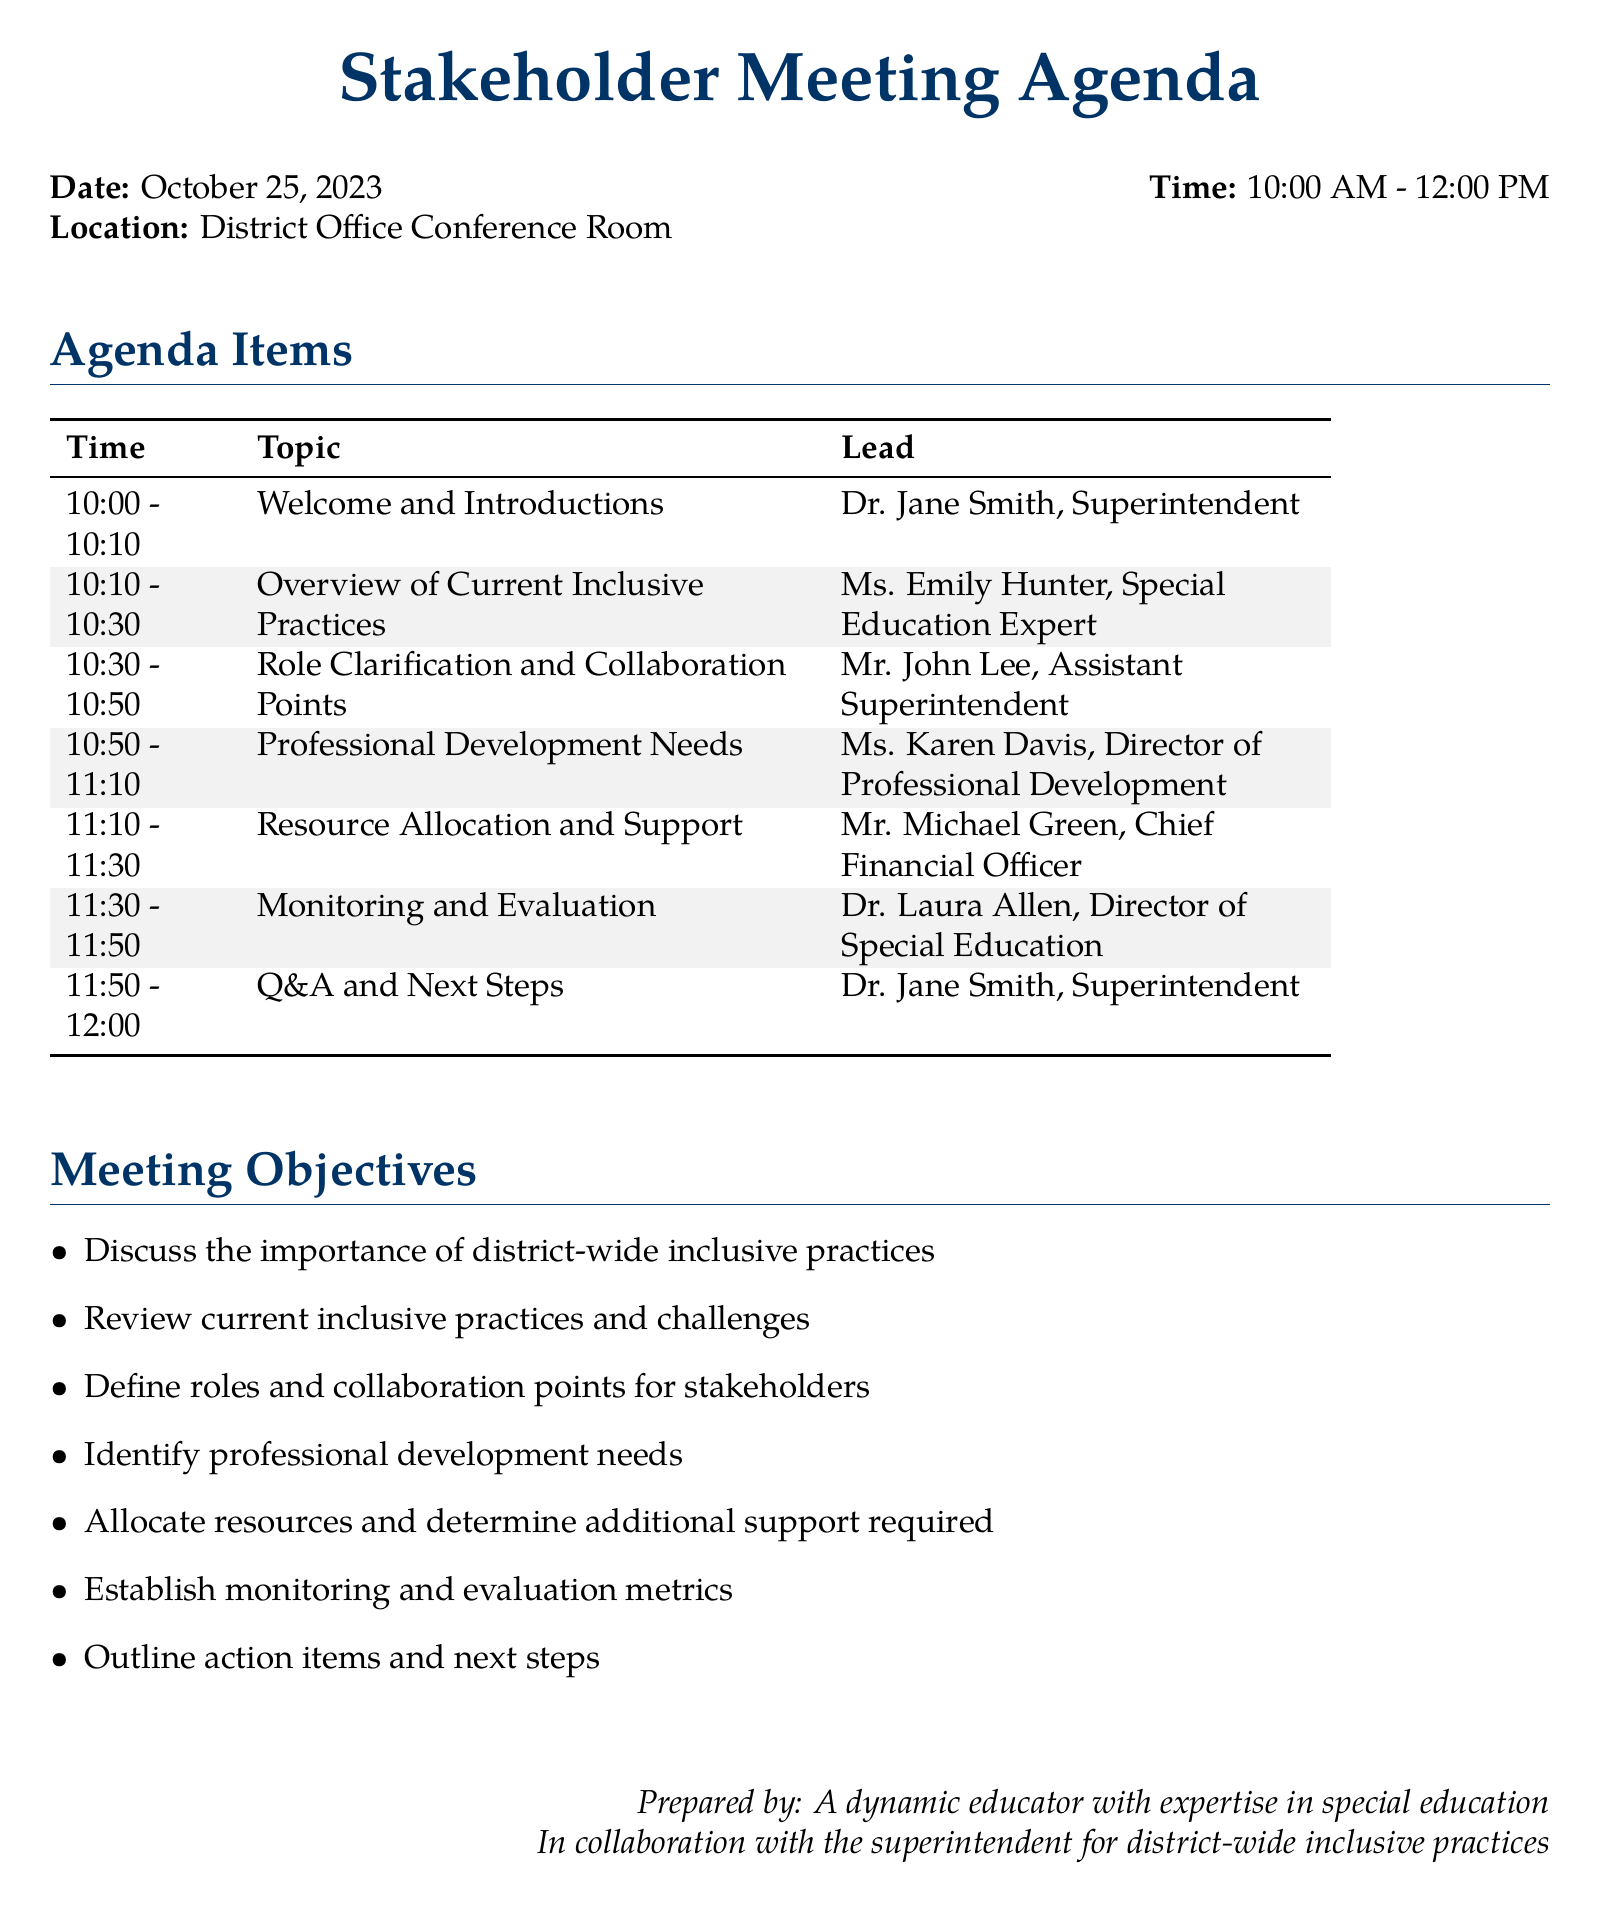What is the date of the meeting? The date of the meeting is clearly stated at the beginning of the agenda.
Answer: October 25, 2023 Who is leading the overview of current inclusive practices? The lead for this agenda item is specified in the document.
Answer: Ms. Emily Hunter What time does the resource allocation and support discussion start? The meeting agenda provides the starting time for each topic.
Answer: 11:10 What is one of the objectives of the meeting? The objectives are outlined in the meeting objectives section.
Answer: Discuss the importance of district-wide inclusive practices Who will provide information on professional development needs? The specific individual responsible for this agenda item is detailed in the table.
Answer: Ms. Karen Davis What role does Mr. John Lee have in this meeting? The document indicates the specific topic he is leading.
Answer: Assistant Superintendent 